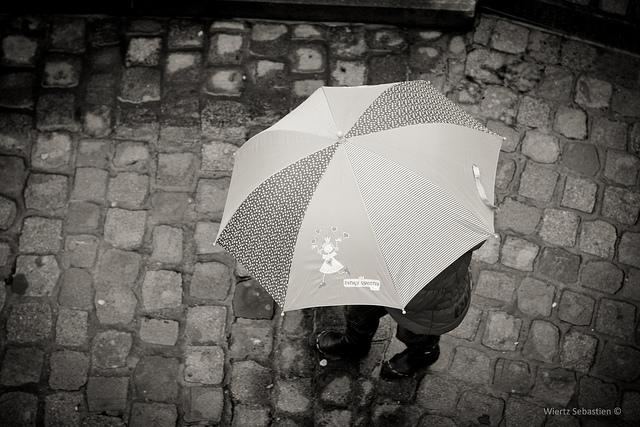How many people are visible?
Quick response, please. 2. What type of stone is that?
Give a very brief answer. Cobblestone. Is the umbrella the same color?
Quick response, please. No. 